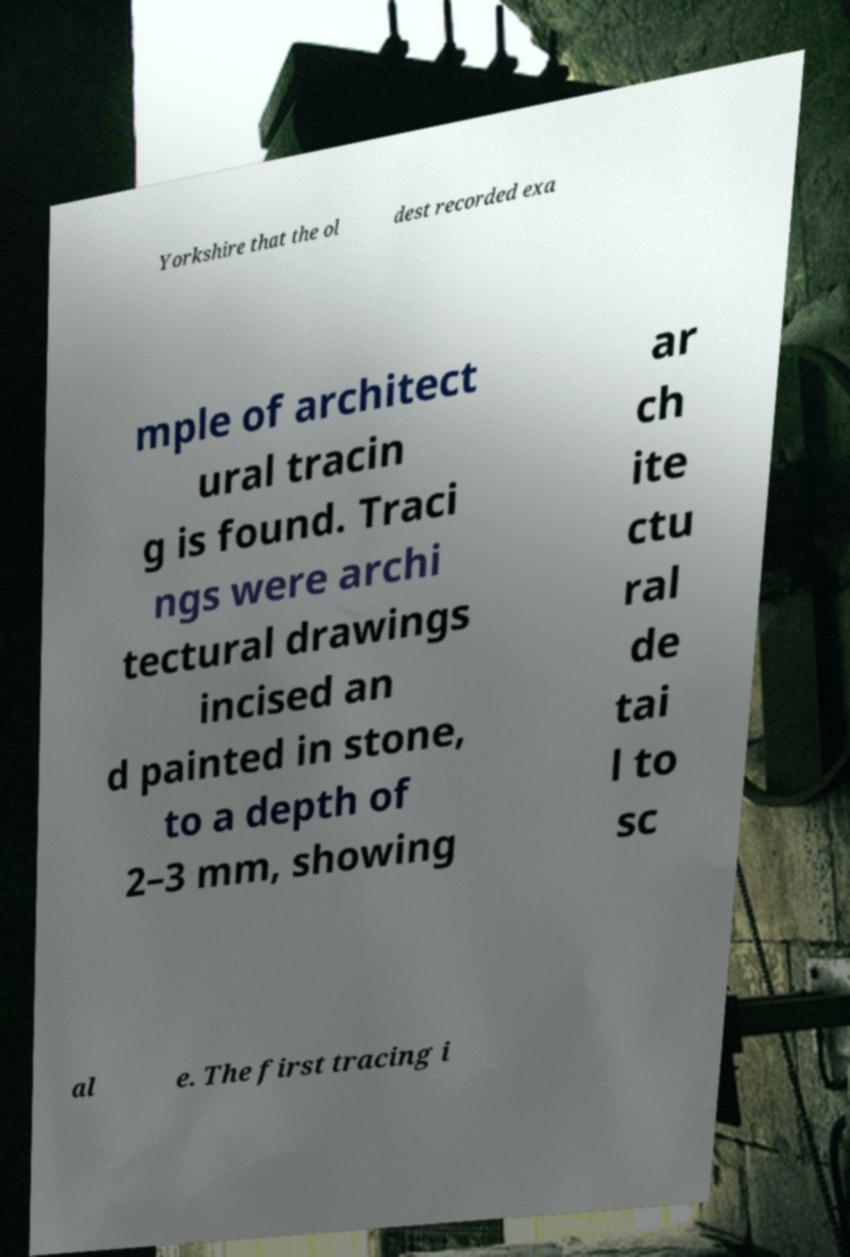Could you extract and type out the text from this image? Yorkshire that the ol dest recorded exa mple of architect ural tracin g is found. Traci ngs were archi tectural drawings incised an d painted in stone, to a depth of 2–3 mm, showing ar ch ite ctu ral de tai l to sc al e. The first tracing i 